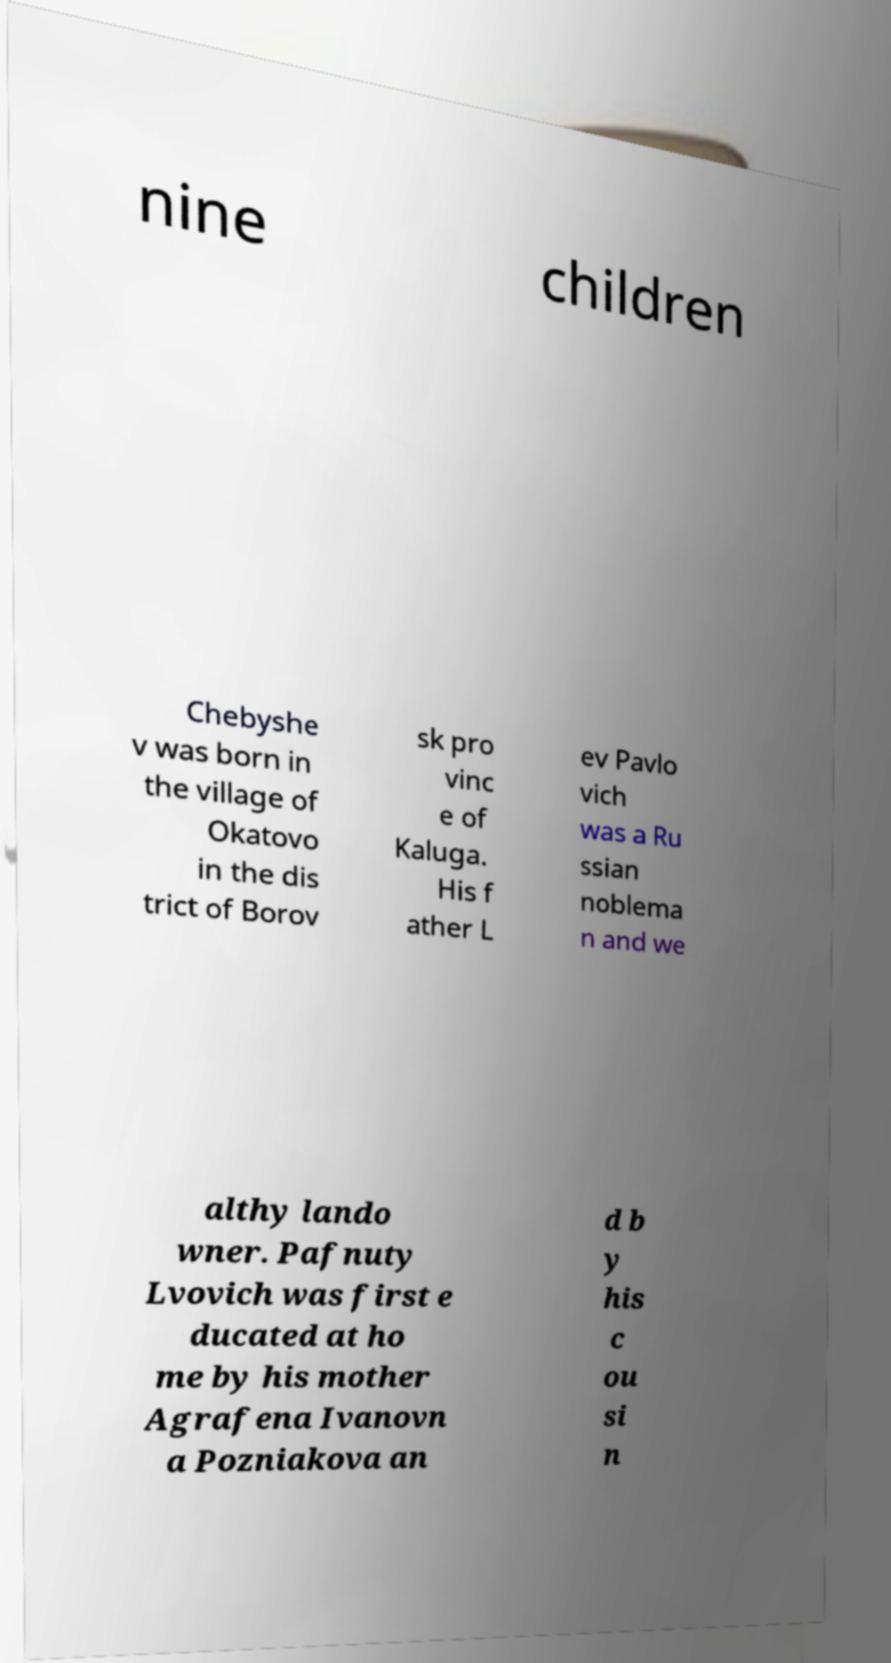Can you accurately transcribe the text from the provided image for me? nine children Chebyshe v was born in the village of Okatovo in the dis trict of Borov sk pro vinc e of Kaluga. His f ather L ev Pavlo vich was a Ru ssian noblema n and we althy lando wner. Pafnuty Lvovich was first e ducated at ho me by his mother Agrafena Ivanovn a Pozniakova an d b y his c ou si n 